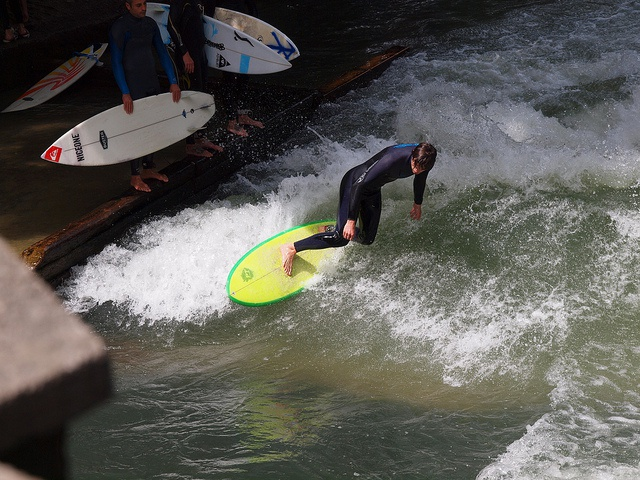Describe the objects in this image and their specific colors. I can see surfboard in black, darkgray, and gray tones, people in black, gray, and maroon tones, surfboard in black, khaki, olive, and lightgray tones, people in black, maroon, navy, and gray tones, and people in black, maroon, gray, and navy tones in this image. 